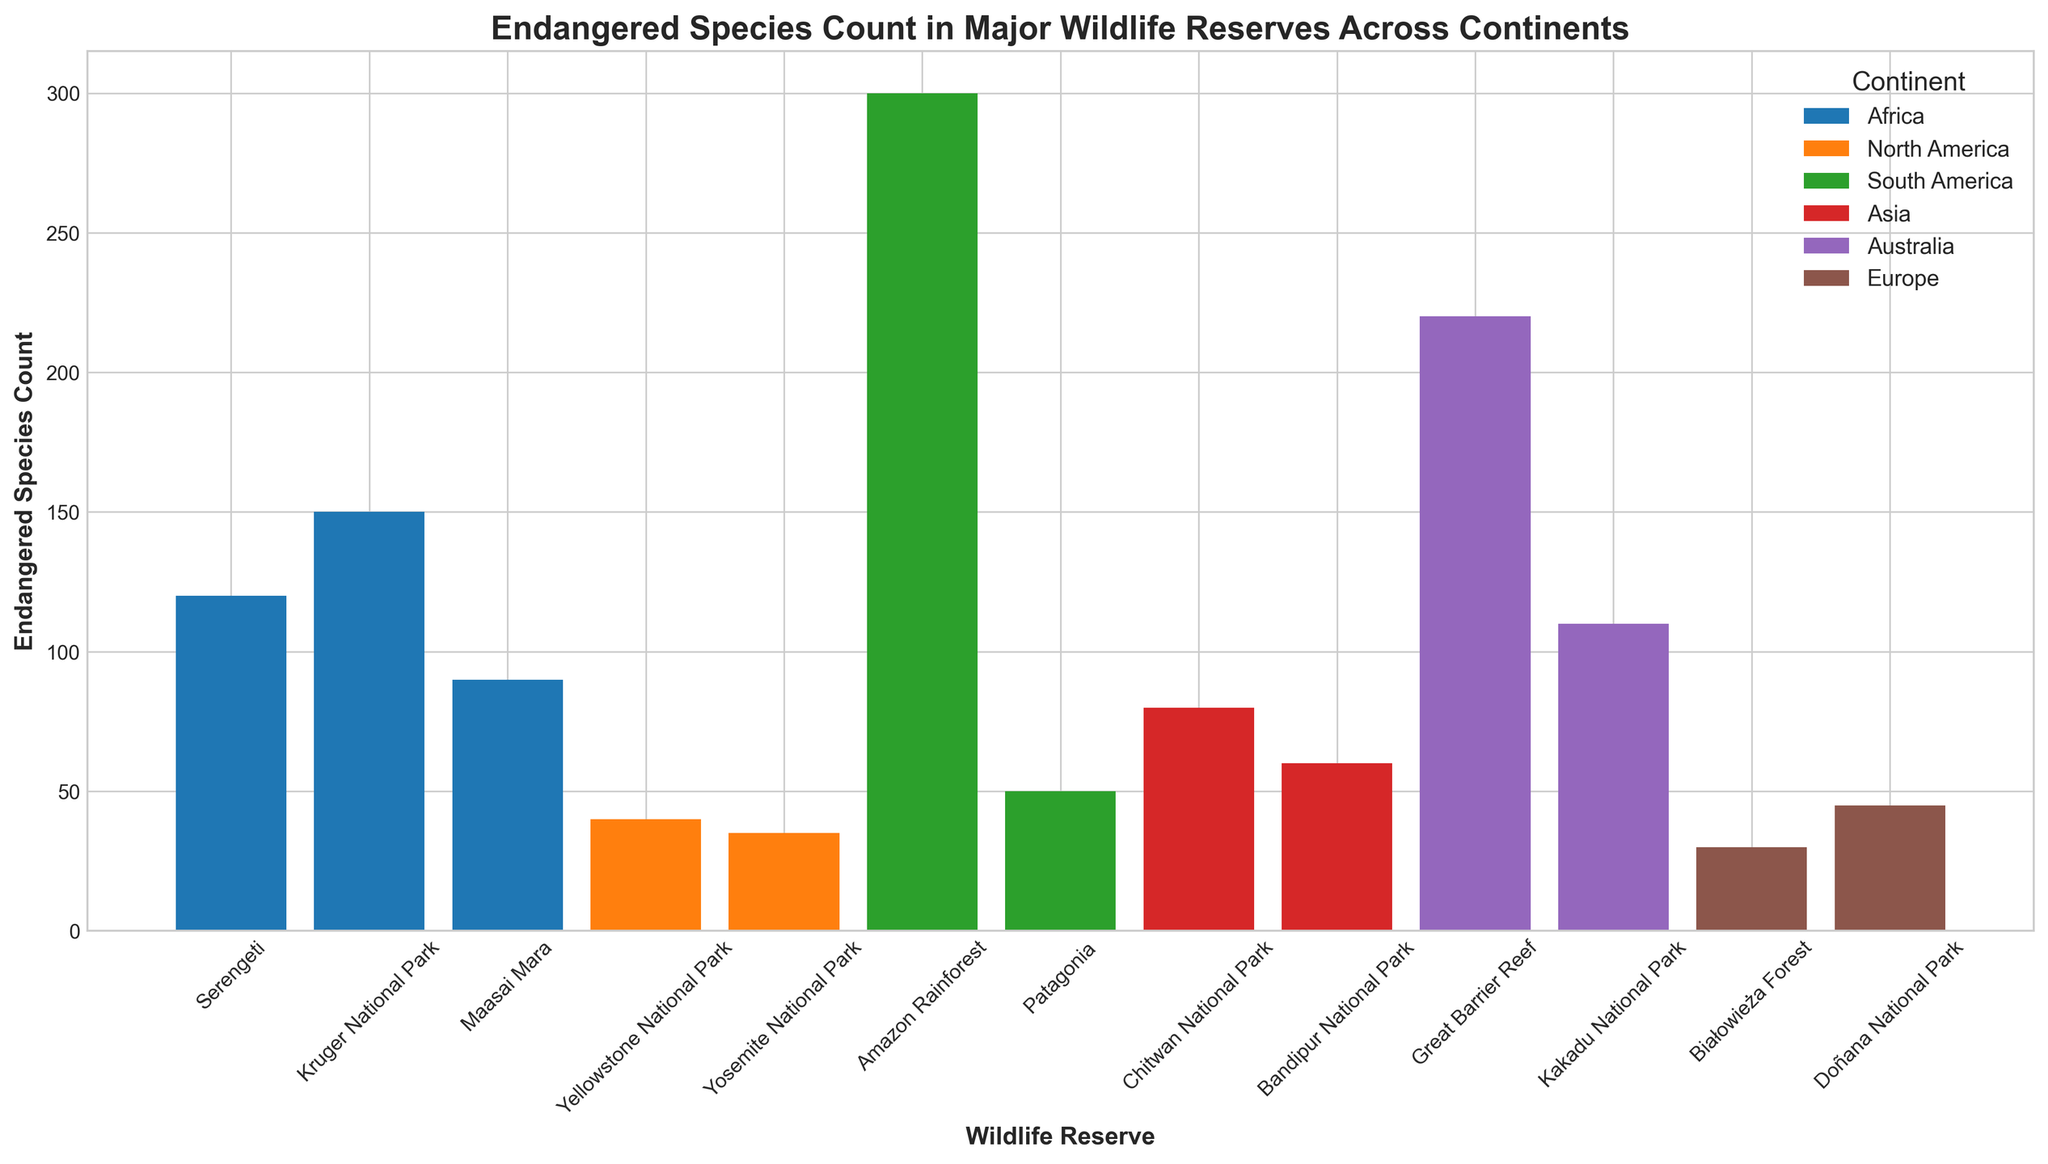Which wildlife reserve has the highest count of endangered species? To determine the wildlife reserve with the highest count, we simply look for the tallest bar in the plot. The data given shows it's the Amazon Rainforest in South America with 300 endangered species.
Answer: Amazon Rainforest Which continent has the most wildlife reserves listed in the figure? To find the continent with the most wildlife reserves, we count the number of bars associated with each continent. Africa has three bars (Serengeti, Kruger National Park, and Maasai Mara), making it the continent with the most reserves listed.
Answer: Africa How does the endangered species count in the Great Barrier Reef compare to the combined count of Yosemite National Park and Yellowstone National Park? The Great Barrier Reef has 220 endangered species. Yosemite has 35, and Yellowstone has 40. The combined count for the North American reserves is 35 + 40 = 75. Since 220 is greater than 75, the Great Barrier Reef has more endangered species.
Answer: Greater What's the average count of endangered species in the wildlife reserves on the Asian continent? The Asian reserves listed are Chitwan National Park (80) and Bandipur National Park (60). Therefore, the average is (80 + 60) / 2 = 140 / 2 = 70.
Answer: 70 Which wildlife reserve in Europe has a higher count of endangered species: Białowieża Forest or Doñana National Park? Comparing the two European reserves, Białowieża Forest has 30 endangered species, and Doñana National Park has 45. Therefore, Doñana National Park has a higher count.
Answer: Doñana National Park What is the total count of endangered species in all the wildlife reserves in Australia? The reserves in Australia are Great Barrier Reef and Kakadu National Park. The counts are 220 and 110 respectively. So, the total count is 220 + 110 = 330.
Answer: 330 How does the count for Serengeti compare with Maasai Mara? The Serengeti has 120 endangered species, while Maasai Mara has 90. Therefore, Serengeti has more.
Answer: More What is the median endangered species count for all the reserves listed? First, we list all counts: 120, 150, 90, 40, 35, 300, 50, 80, 60, 220, 110, 30, 45. Then, we sort them: 30, 35, 40, 45, 50, 60, 80, 90, 110, 120, 150, 220, 300. The middle value is the 7th value in the ordered list, which is 80.
Answer: 80 How much more endangered species does Kruger National Park have compared to Białowieża Forest? Kruger National Park has 150 endangered species and Białowieża Forest has 30. The difference is 150 - 30 = 120.
Answer: 120 